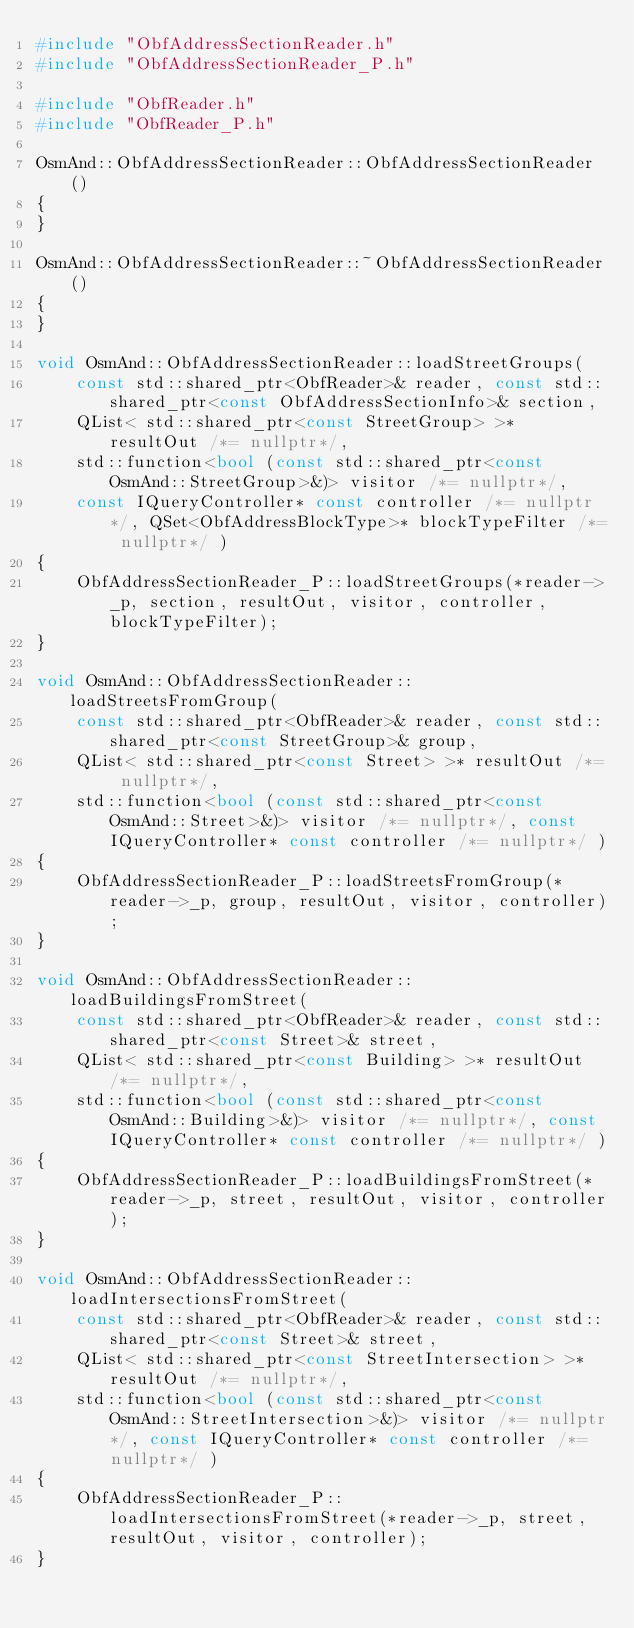<code> <loc_0><loc_0><loc_500><loc_500><_C++_>#include "ObfAddressSectionReader.h"
#include "ObfAddressSectionReader_P.h"

#include "ObfReader.h"
#include "ObfReader_P.h"

OsmAnd::ObfAddressSectionReader::ObfAddressSectionReader()
{
}

OsmAnd::ObfAddressSectionReader::~ObfAddressSectionReader()
{
}

void OsmAnd::ObfAddressSectionReader::loadStreetGroups(
    const std::shared_ptr<ObfReader>& reader, const std::shared_ptr<const ObfAddressSectionInfo>& section,
    QList< std::shared_ptr<const StreetGroup> >* resultOut /*= nullptr*/,
    std::function<bool (const std::shared_ptr<const OsmAnd::StreetGroup>&)> visitor /*= nullptr*/,
    const IQueryController* const controller /*= nullptr*/, QSet<ObfAddressBlockType>* blockTypeFilter /*= nullptr*/ )
{
    ObfAddressSectionReader_P::loadStreetGroups(*reader->_p, section, resultOut, visitor, controller, blockTypeFilter);
}

void OsmAnd::ObfAddressSectionReader::loadStreetsFromGroup(
    const std::shared_ptr<ObfReader>& reader, const std::shared_ptr<const StreetGroup>& group,
    QList< std::shared_ptr<const Street> >* resultOut /*= nullptr*/,
    std::function<bool (const std::shared_ptr<const OsmAnd::Street>&)> visitor /*= nullptr*/, const IQueryController* const controller /*= nullptr*/ )
{
    ObfAddressSectionReader_P::loadStreetsFromGroup(*reader->_p, group, resultOut, visitor, controller);
}

void OsmAnd::ObfAddressSectionReader::loadBuildingsFromStreet(
    const std::shared_ptr<ObfReader>& reader, const std::shared_ptr<const Street>& street,
    QList< std::shared_ptr<const Building> >* resultOut /*= nullptr*/,
    std::function<bool (const std::shared_ptr<const OsmAnd::Building>&)> visitor /*= nullptr*/, const IQueryController* const controller /*= nullptr*/ )
{
    ObfAddressSectionReader_P::loadBuildingsFromStreet(*reader->_p, street, resultOut, visitor, controller);
}

void OsmAnd::ObfAddressSectionReader::loadIntersectionsFromStreet(
    const std::shared_ptr<ObfReader>& reader, const std::shared_ptr<const Street>& street,
    QList< std::shared_ptr<const StreetIntersection> >* resultOut /*= nullptr*/,
    std::function<bool (const std::shared_ptr<const OsmAnd::StreetIntersection>&)> visitor /*= nullptr*/, const IQueryController* const controller /*= nullptr*/ )
{
    ObfAddressSectionReader_P::loadIntersectionsFromStreet(*reader->_p, street, resultOut, visitor, controller);
}
</code> 